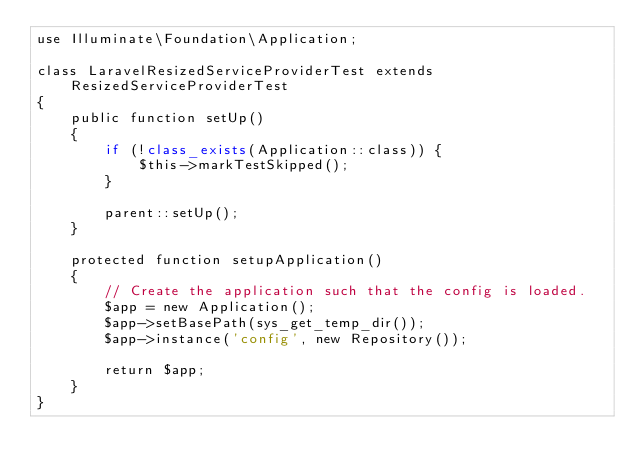<code> <loc_0><loc_0><loc_500><loc_500><_PHP_>use Illuminate\Foundation\Application;

class LaravelResizedServiceProviderTest extends ResizedServiceProviderTest
{
    public function setUp()
    {
        if (!class_exists(Application::class)) {
            $this->markTestSkipped();
        }

        parent::setUp();
    }

    protected function setupApplication()
    {
        // Create the application such that the config is loaded.
        $app = new Application();
        $app->setBasePath(sys_get_temp_dir());
        $app->instance('config', new Repository());

        return $app;
    }
}
</code> 